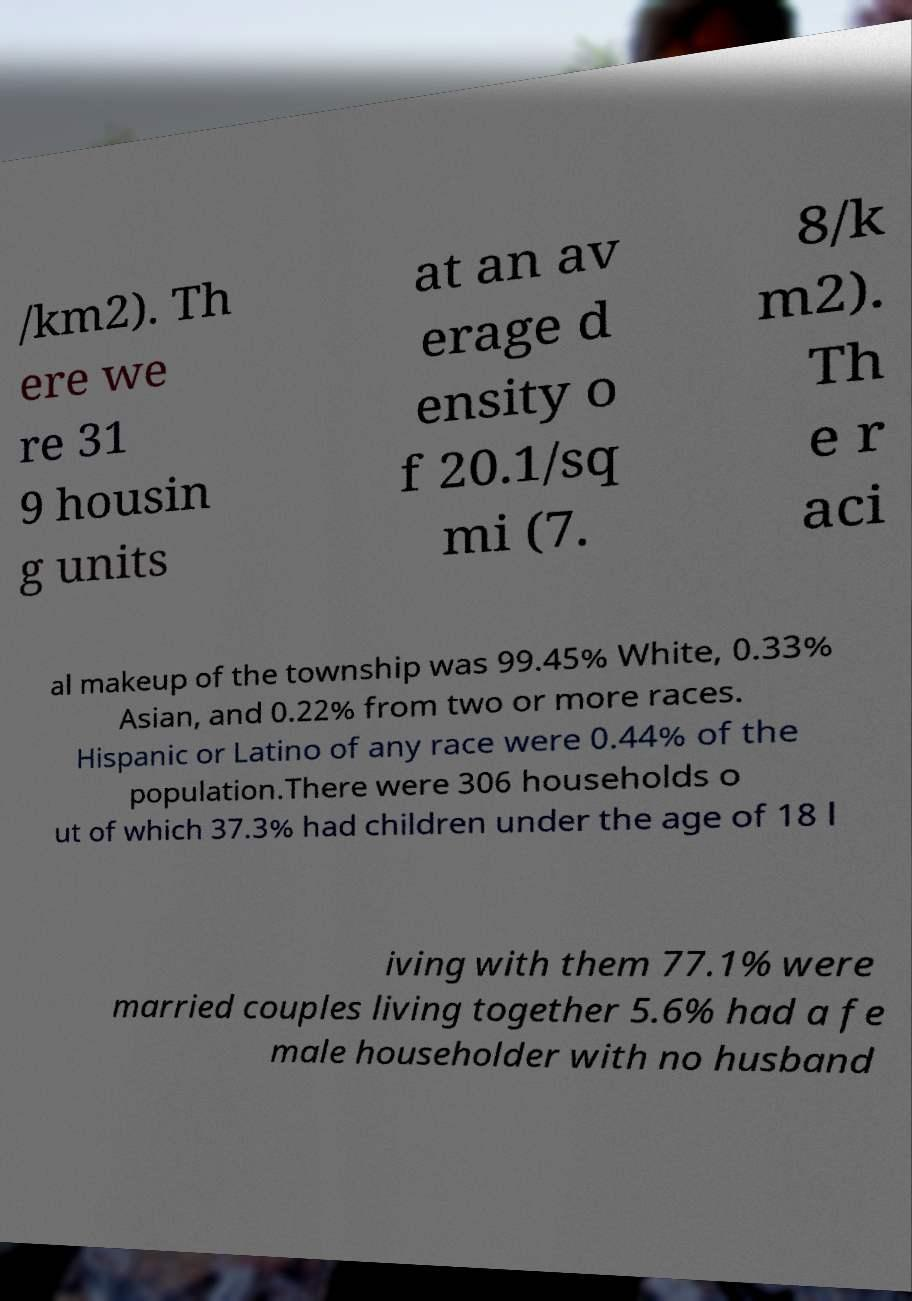I need the written content from this picture converted into text. Can you do that? /km2). Th ere we re 31 9 housin g units at an av erage d ensity o f 20.1/sq mi (7. 8/k m2). Th e r aci al makeup of the township was 99.45% White, 0.33% Asian, and 0.22% from two or more races. Hispanic or Latino of any race were 0.44% of the population.There were 306 households o ut of which 37.3% had children under the age of 18 l iving with them 77.1% were married couples living together 5.6% had a fe male householder with no husband 